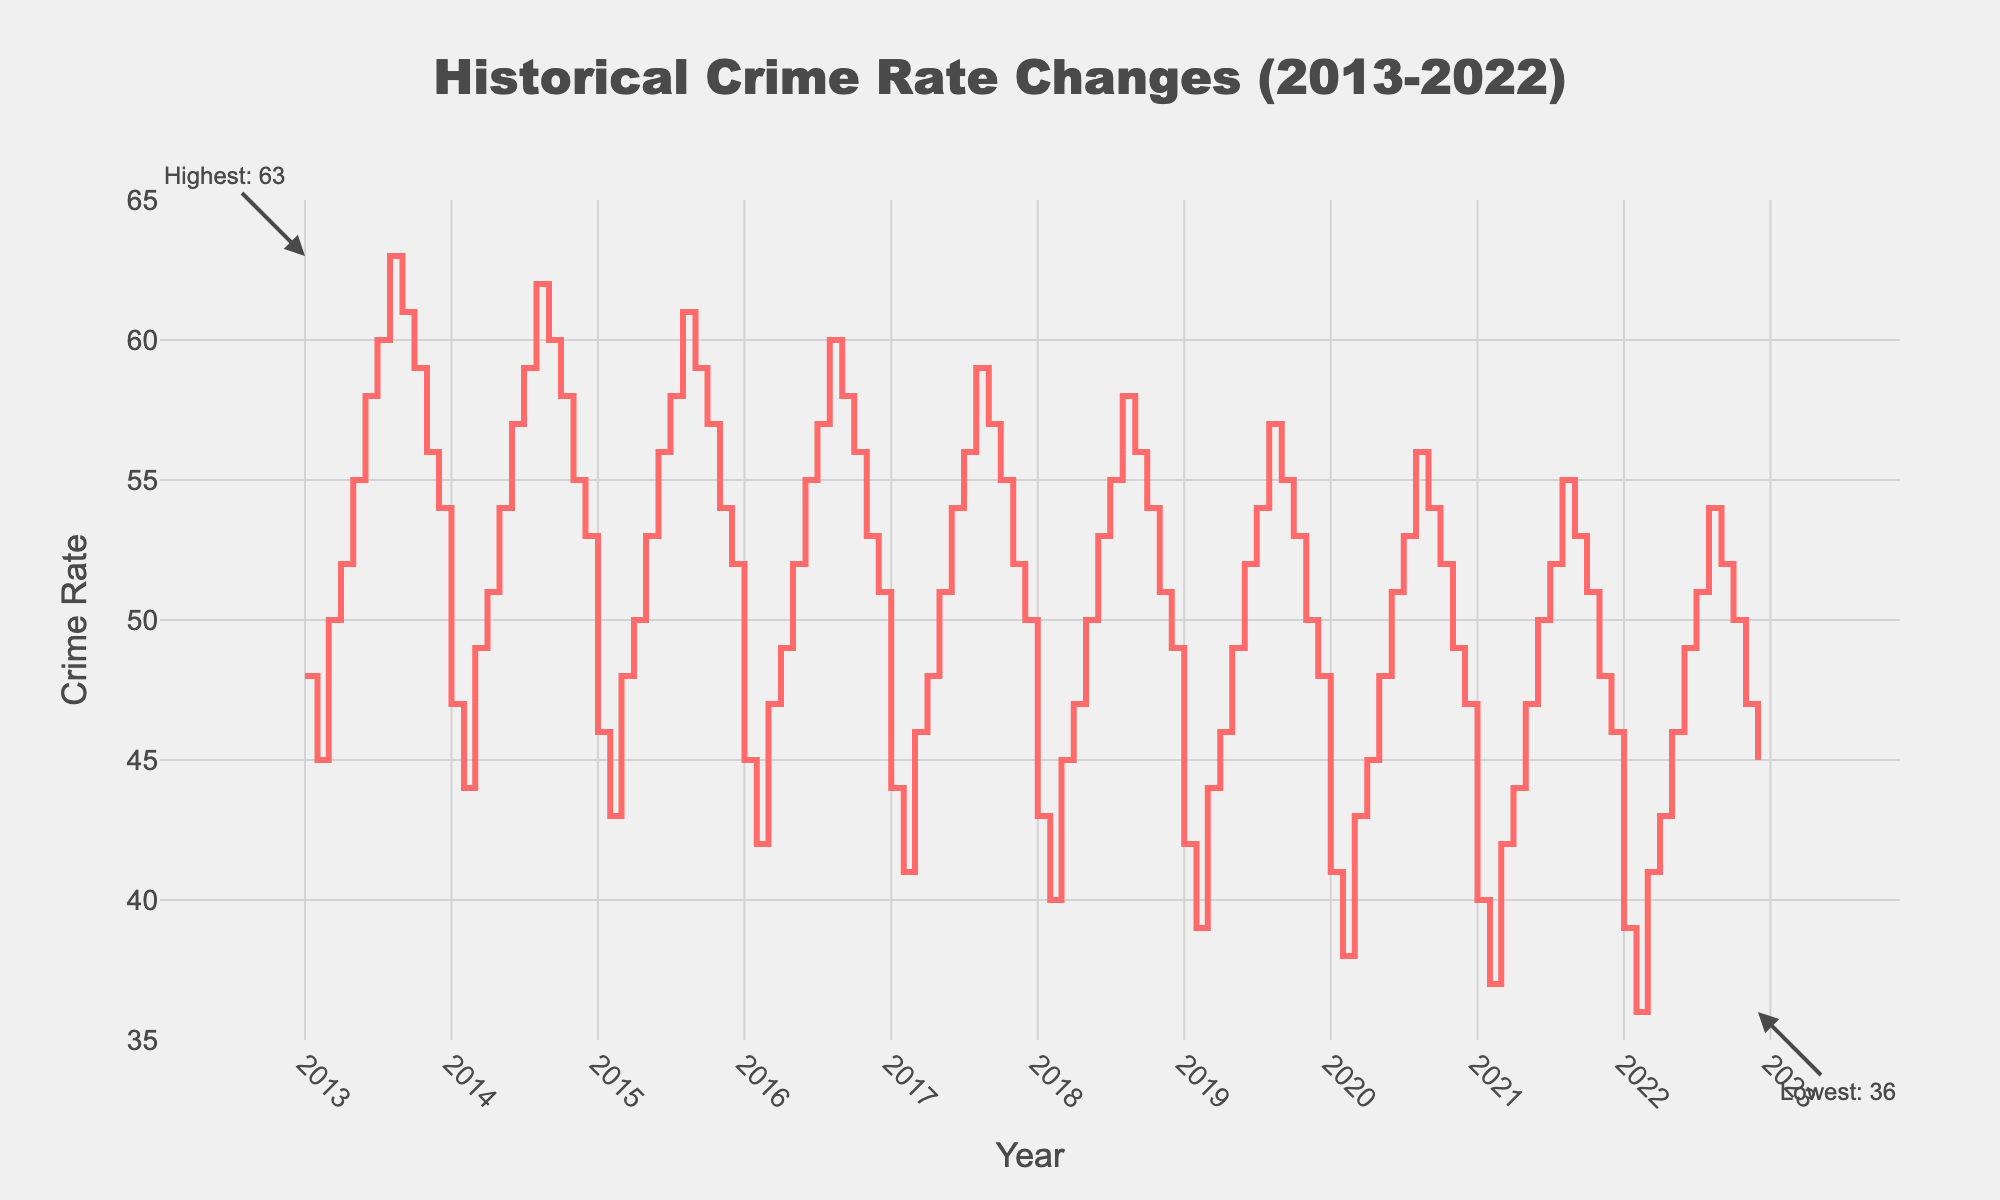When did the highest crime rate occur? The highest crime rate is marked with an annotation on the plot. It indicates the highest crime rate occurring in January 2013.
Answer: January 2013 What is the value of the highest recorded crime rate? The annotation for the highest crime rate explicitly states "Highest: 63".
Answer: 63 What is the general trend in crime rate from January 2013 to December 2022? Observing the trend line, the crime rate generally decreases from around 48 to 45 over the decade, indicating a downward trend.
Answer: Downward Which month and year recorded the lowest crime rate? The lowest crime rate is also marked with an annotation on the plot. It states the lowest crime rate occurring in December 2022.
Answer: December 2022 What's the difference in crime rates between the highest and lowest recorded values? The highest crime rate is 63, and the lowest crime rate is 36. The difference is 63 - 36 = 27.
Answer: 27 How does the crime rate in January 2020 compare to January 2013? In January 2013, the crime rate was 48, while in January 2020, it was 41. Thus, the rate decreased by 48 - 41 = 7.
Answer: Decreased by 7 Which year shows the most significant decrease in crime rate from the beginning to the end of the year? From the stair plot lines, examining the difference within each year, the year 2021 shows the most significant drop, from 40 in January to 36 in December, a decrease of 4.
Answer: 2021 What is the average crime rate for the month of July over the decade? Taking values for July from each year: 2013 (60), 2014 (59), 2015 (58), 2016 (57), 2017 (56), 2018 (55), 2019 (54), 2020 (53), 2021 (52), 2022 (51), and calculating their average: (60+59+58+57+56+55+54+53+52+51)/10 = 55.5.
Answer: 55.5 What is the overall trend in crime rate during the months of December each year? Checking the plot for December values: starting with 54 in 2013, it decreases most years and ends at 45 by 2022, showing a decreasing trend.
Answer: Decreasing 